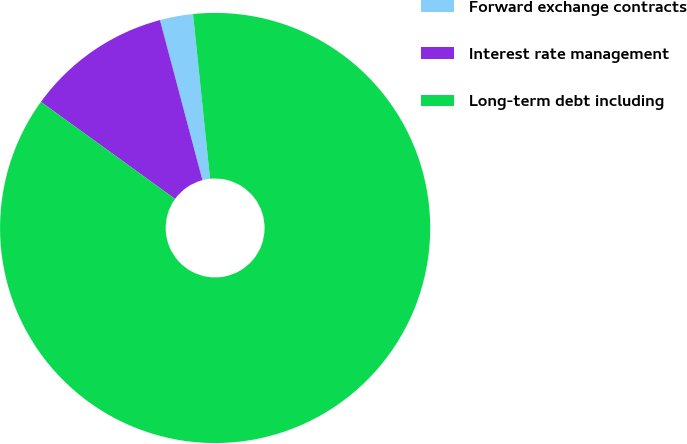Convert chart to OTSL. <chart><loc_0><loc_0><loc_500><loc_500><pie_chart><fcel>Forward exchange contracts<fcel>Interest rate management<fcel>Long-term debt including<nl><fcel>2.49%<fcel>10.9%<fcel>86.6%<nl></chart> 